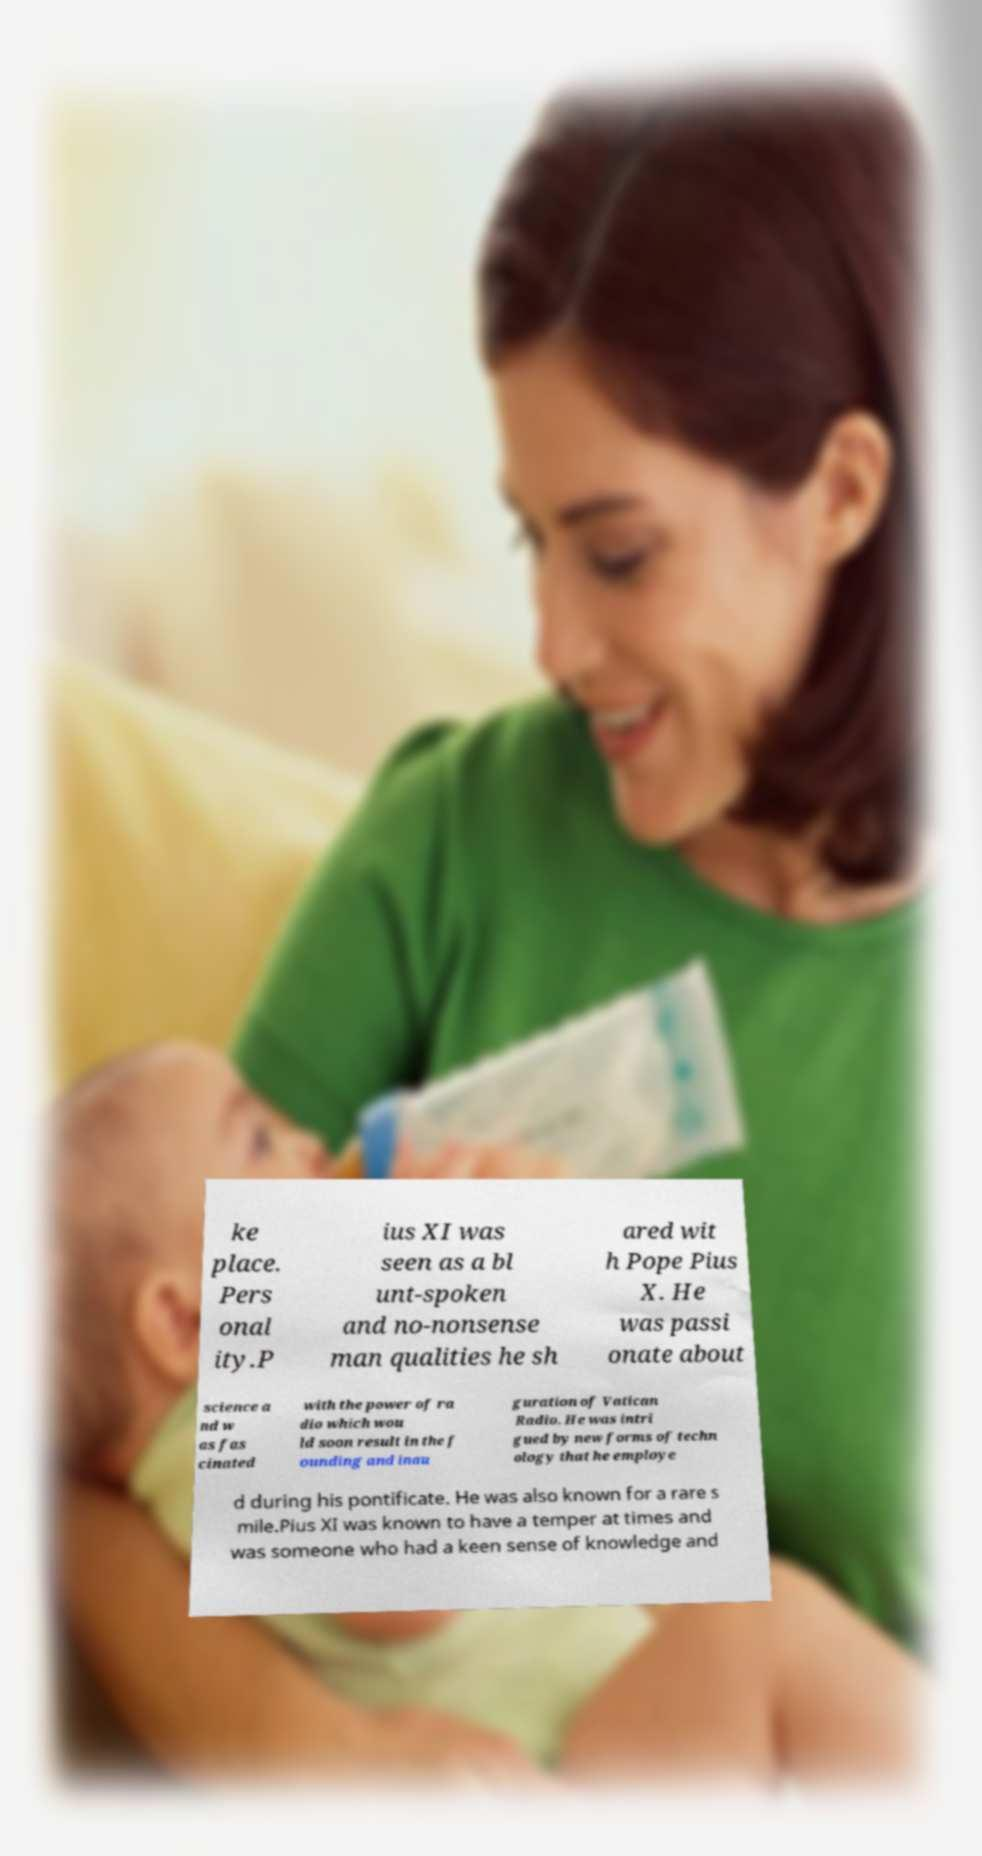For documentation purposes, I need the text within this image transcribed. Could you provide that? ke place. Pers onal ity.P ius XI was seen as a bl unt-spoken and no-nonsense man qualities he sh ared wit h Pope Pius X. He was passi onate about science a nd w as fas cinated with the power of ra dio which wou ld soon result in the f ounding and inau guration of Vatican Radio. He was intri gued by new forms of techn ology that he employe d during his pontificate. He was also known for a rare s mile.Pius XI was known to have a temper at times and was someone who had a keen sense of knowledge and 